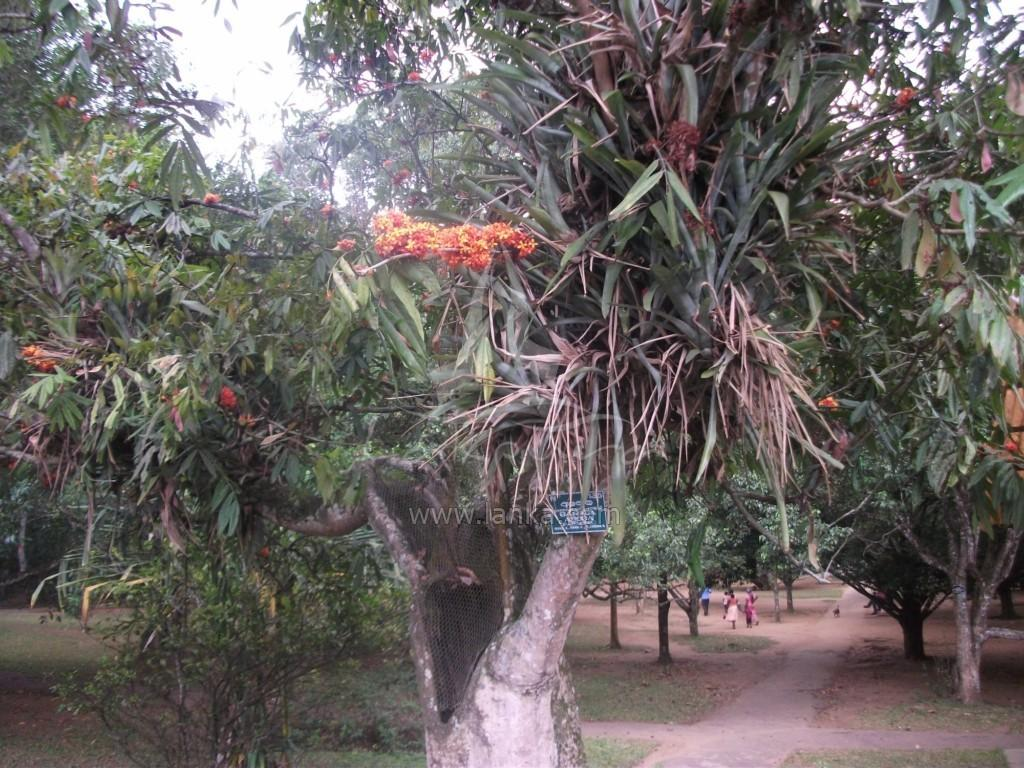What type of plant is featured in the image? There is a tree with leaves and flowers in the image. Can you describe the background of the image? There are many trees in the background of the image. What else can be seen in the image besides the tree? There are people standing on the ground in the image. What type of book is being read by the tree in the image? There is no book present in the image, and trees do not read books. 